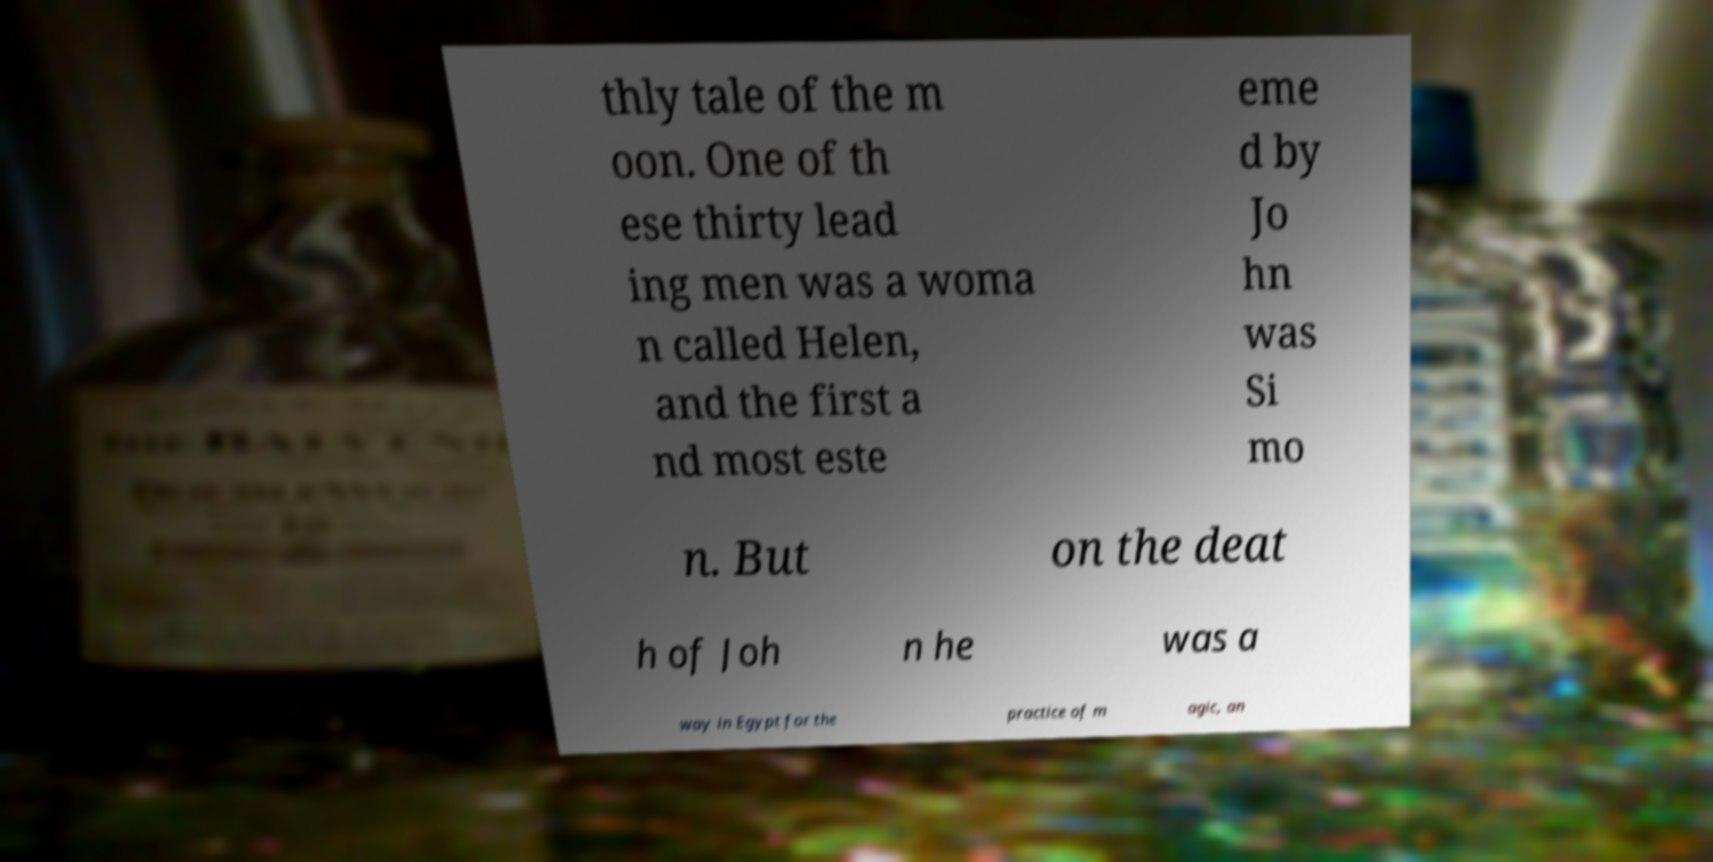For documentation purposes, I need the text within this image transcribed. Could you provide that? thly tale of the m oon. One of th ese thirty lead ing men was a woma n called Helen, and the first a nd most este eme d by Jo hn was Si mo n. But on the deat h of Joh n he was a way in Egypt for the practice of m agic, an 